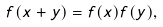Convert formula to latex. <formula><loc_0><loc_0><loc_500><loc_500>f ( x + y ) = f ( x ) f ( y ) ,</formula> 